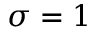<formula> <loc_0><loc_0><loc_500><loc_500>\sigma = 1</formula> 